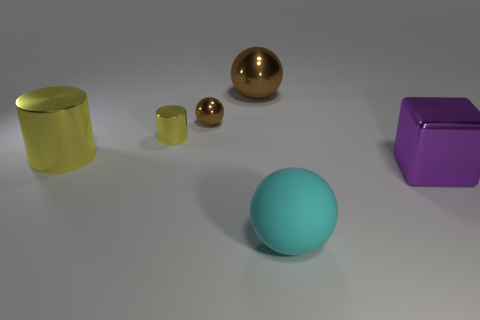Are there fewer matte balls that are to the left of the large rubber thing than big spheres?
Your answer should be compact. Yes. How many large brown metallic spheres are in front of the large matte sphere?
Your response must be concise. 0. There is a metallic thing on the right side of the ball in front of the purple thing behind the large cyan thing; how big is it?
Your response must be concise. Large. There is a purple metallic thing; is its shape the same as the big yellow shiny thing that is on the left side of the large cyan rubber thing?
Your answer should be very brief. No. What size is the other cylinder that is the same material as the small cylinder?
Keep it short and to the point. Large. Are there any other things that have the same color as the small sphere?
Offer a terse response. Yes. What material is the brown sphere on the left side of the metal object that is behind the brown shiny object that is in front of the large brown metal thing?
Offer a very short reply. Metal. What number of metallic things are cyan things or big balls?
Give a very brief answer. 1. Is the matte ball the same color as the big shiny cube?
Provide a short and direct response. No. Are there any other things that have the same material as the small yellow cylinder?
Your answer should be compact. Yes. 